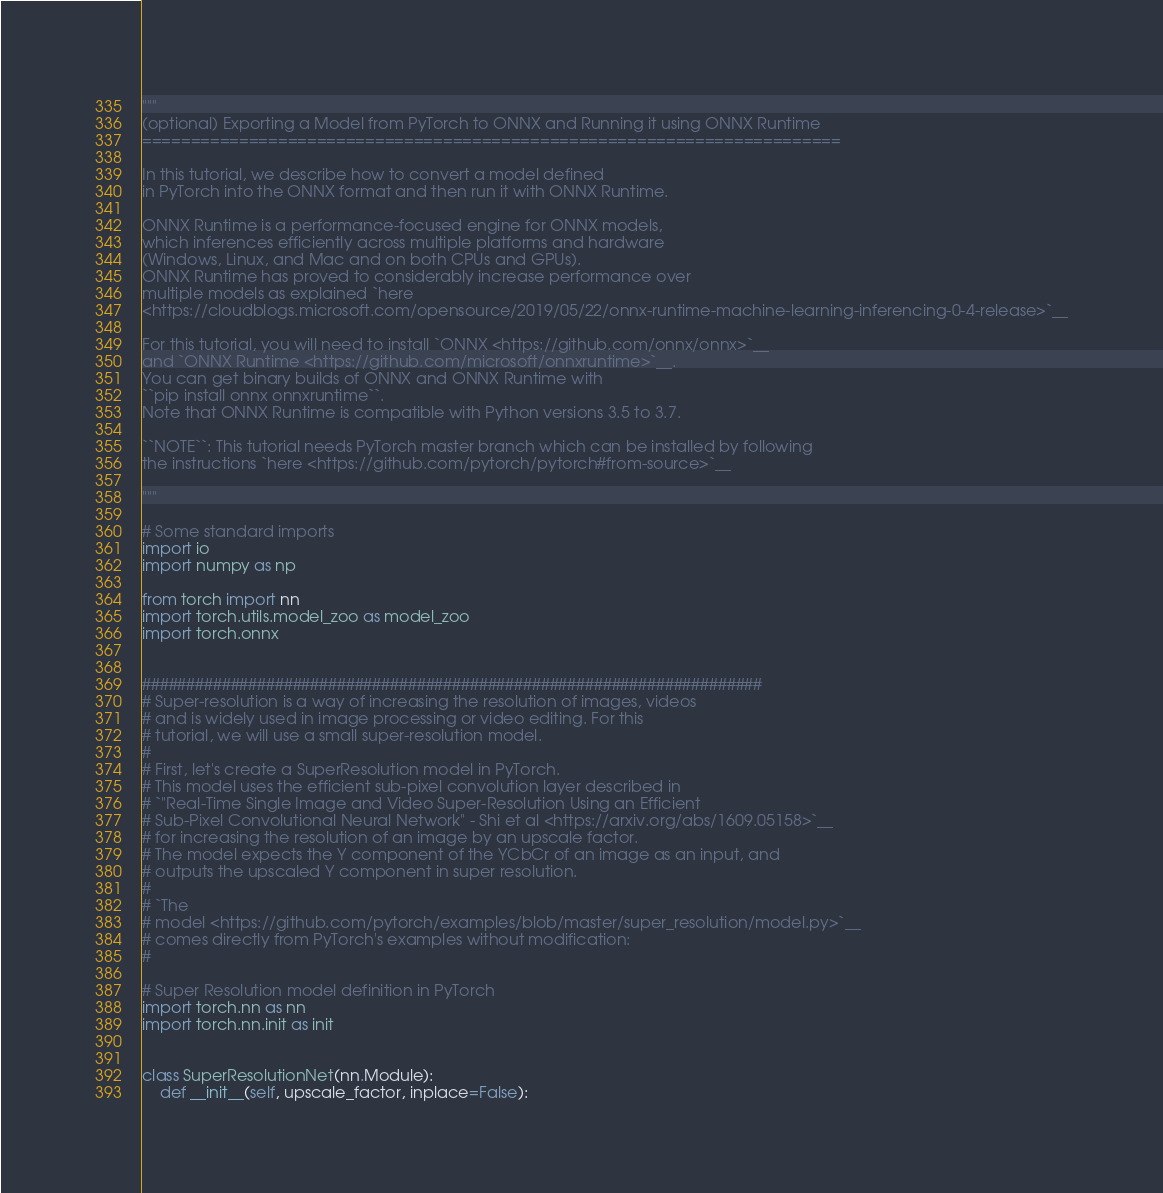<code> <loc_0><loc_0><loc_500><loc_500><_Python_>"""
(optional) Exporting a Model from PyTorch to ONNX and Running it using ONNX Runtime
========================================================================

In this tutorial, we describe how to convert a model defined
in PyTorch into the ONNX format and then run it with ONNX Runtime.

ONNX Runtime is a performance-focused engine for ONNX models,
which inferences efficiently across multiple platforms and hardware
(Windows, Linux, and Mac and on both CPUs and GPUs).
ONNX Runtime has proved to considerably increase performance over
multiple models as explained `here
<https://cloudblogs.microsoft.com/opensource/2019/05/22/onnx-runtime-machine-learning-inferencing-0-4-release>`__

For this tutorial, you will need to install `ONNX <https://github.com/onnx/onnx>`__
and `ONNX Runtime <https://github.com/microsoft/onnxruntime>`__.
You can get binary builds of ONNX and ONNX Runtime with
``pip install onnx onnxruntime``.
Note that ONNX Runtime is compatible with Python versions 3.5 to 3.7.

``NOTE``: This tutorial needs PyTorch master branch which can be installed by following
the instructions `here <https://github.com/pytorch/pytorch#from-source>`__

"""

# Some standard imports
import io
import numpy as np

from torch import nn
import torch.utils.model_zoo as model_zoo
import torch.onnx


######################################################################
# Super-resolution is a way of increasing the resolution of images, videos
# and is widely used in image processing or video editing. For this
# tutorial, we will use a small super-resolution model.
#
# First, let's create a SuperResolution model in PyTorch.
# This model uses the efficient sub-pixel convolution layer described in
# `"Real-Time Single Image and Video Super-Resolution Using an Efficient
# Sub-Pixel Convolutional Neural Network" - Shi et al <https://arxiv.org/abs/1609.05158>`__
# for increasing the resolution of an image by an upscale factor.
# The model expects the Y component of the YCbCr of an image as an input, and
# outputs the upscaled Y component in super resolution.
#
# `The
# model <https://github.com/pytorch/examples/blob/master/super_resolution/model.py>`__
# comes directly from PyTorch's examples without modification:
#

# Super Resolution model definition in PyTorch
import torch.nn as nn
import torch.nn.init as init


class SuperResolutionNet(nn.Module):
    def __init__(self, upscale_factor, inplace=False):</code> 